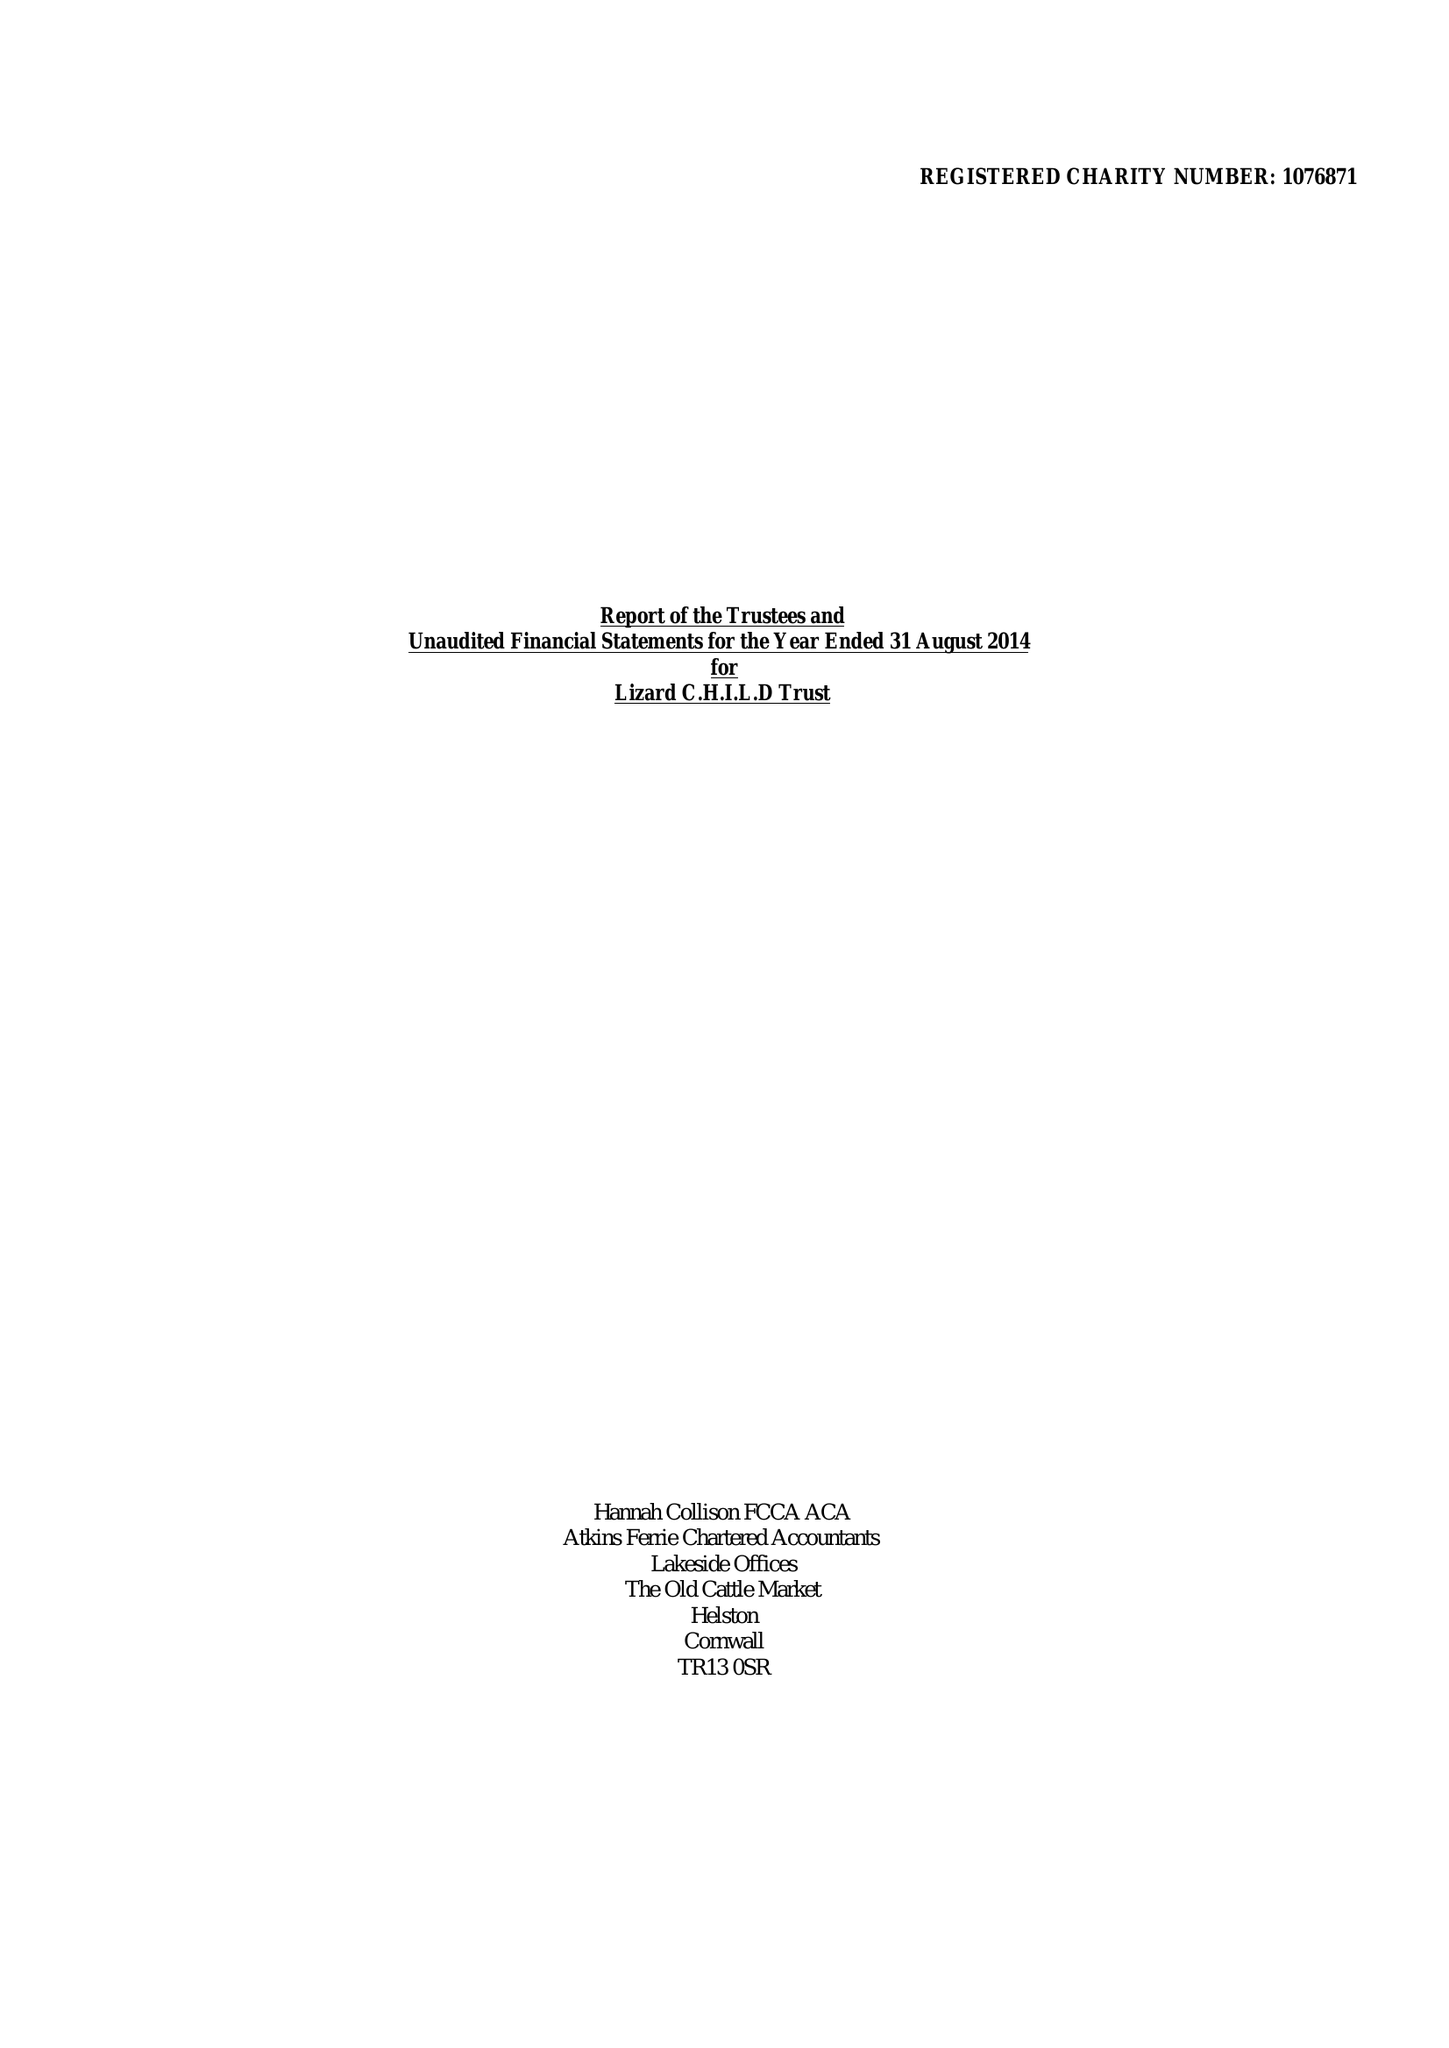What is the value for the spending_annually_in_british_pounds?
Answer the question using a single word or phrase. 234426.00 